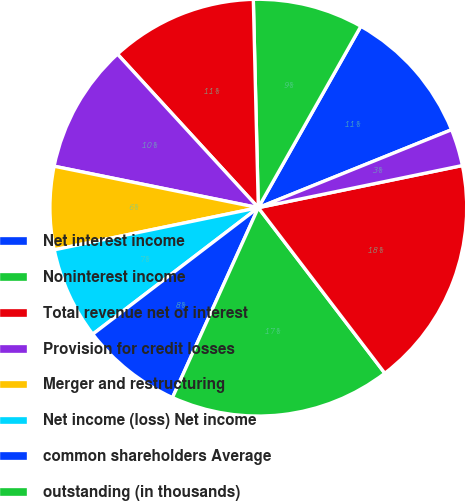Convert chart to OTSL. <chart><loc_0><loc_0><loc_500><loc_500><pie_chart><fcel>Net interest income<fcel>Noninterest income<fcel>Total revenue net of interest<fcel>Provision for credit losses<fcel>Merger and restructuring<fcel>Net income (loss) Net income<fcel>common shareholders Average<fcel>outstanding (in thousands)<fcel>Average diluted common shares<fcel>Total average equity to total<nl><fcel>10.71%<fcel>8.57%<fcel>11.43%<fcel>10.0%<fcel>6.43%<fcel>7.14%<fcel>7.86%<fcel>17.14%<fcel>17.86%<fcel>2.86%<nl></chart> 